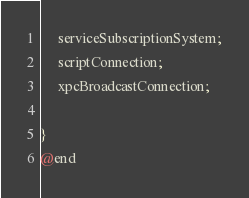<code> <loc_0><loc_0><loc_500><loc_500><_C_>
	 serviceSubscriptionSystem;
	 scriptConnection;
	 xpcBroadcastConnection;

}
@end

</code> 